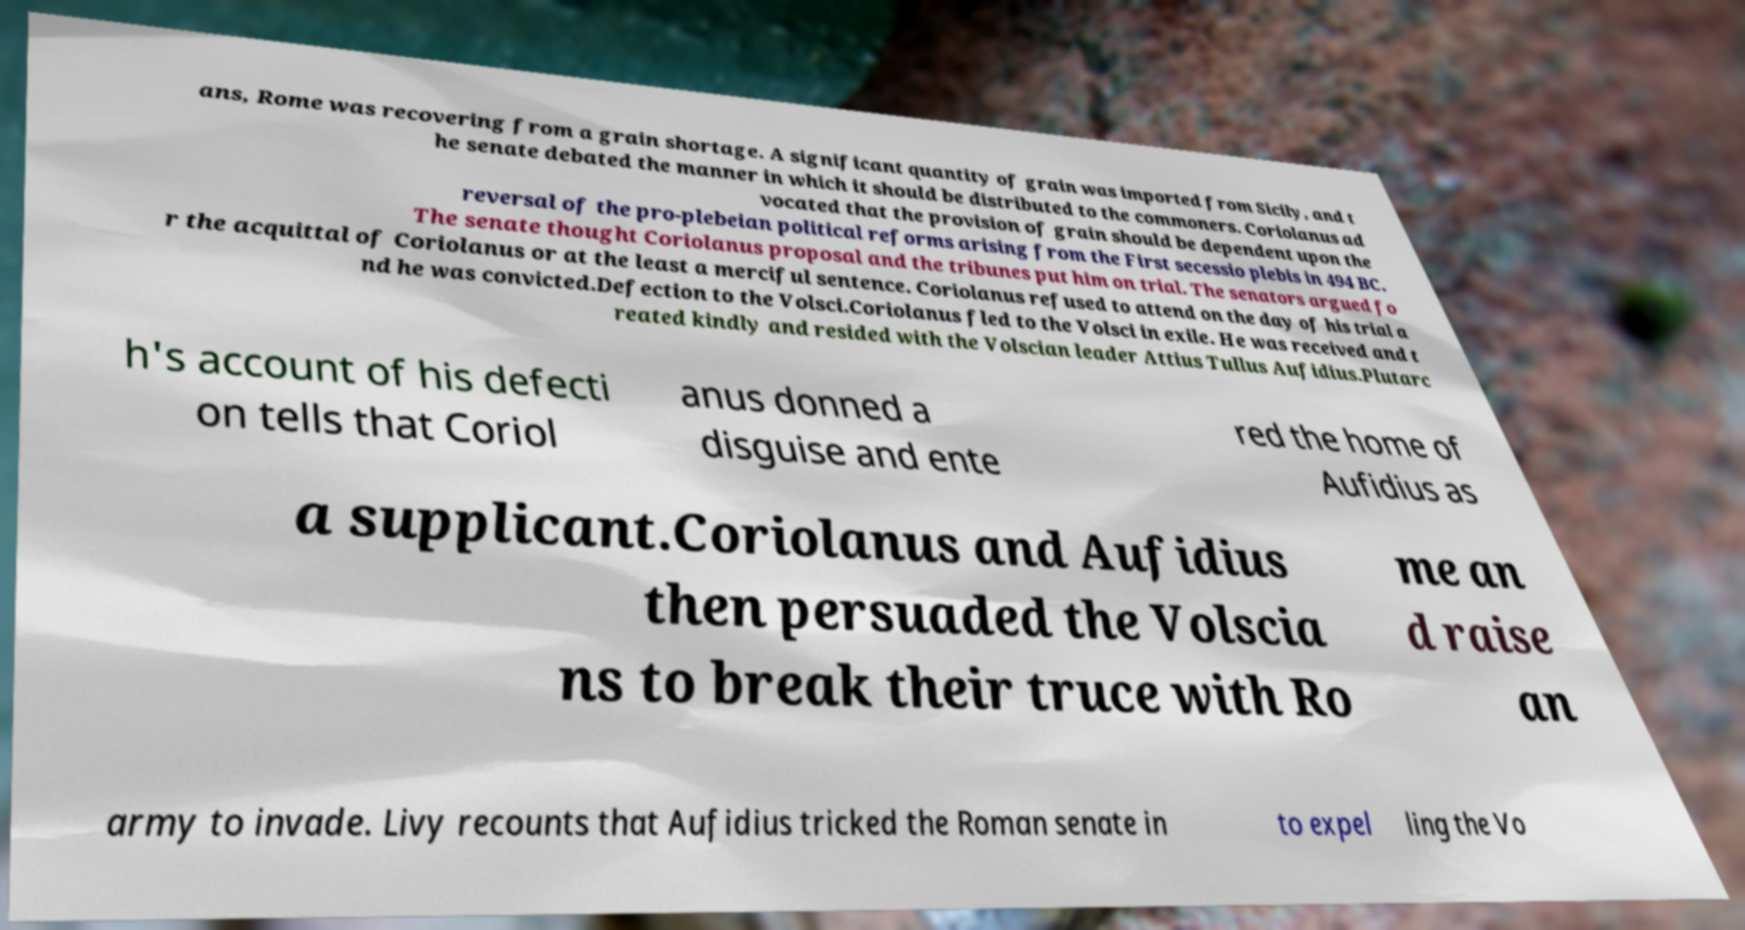What messages or text are displayed in this image? I need them in a readable, typed format. ans, Rome was recovering from a grain shortage. A significant quantity of grain was imported from Sicily, and t he senate debated the manner in which it should be distributed to the commoners. Coriolanus ad vocated that the provision of grain should be dependent upon the reversal of the pro-plebeian political reforms arising from the First secessio plebis in 494 BC. The senate thought Coriolanus proposal and the tribunes put him on trial. The senators argued fo r the acquittal of Coriolanus or at the least a merciful sentence. Coriolanus refused to attend on the day of his trial a nd he was convicted.Defection to the Volsci.Coriolanus fled to the Volsci in exile. He was received and t reated kindly and resided with the Volscian leader Attius Tullus Aufidius.Plutarc h's account of his defecti on tells that Coriol anus donned a disguise and ente red the home of Aufidius as a supplicant.Coriolanus and Aufidius then persuaded the Volscia ns to break their truce with Ro me an d raise an army to invade. Livy recounts that Aufidius tricked the Roman senate in to expel ling the Vo 